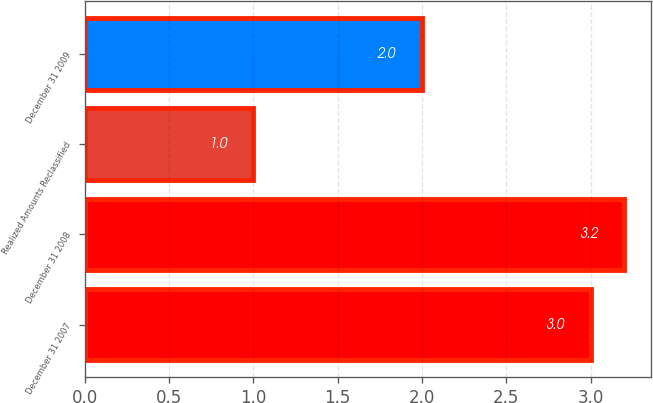<chart> <loc_0><loc_0><loc_500><loc_500><bar_chart><fcel>December 31 2007<fcel>December 31 2008<fcel>Realized Amounts Reclassified<fcel>December 31 2009<nl><fcel>3<fcel>3.2<fcel>1<fcel>2<nl></chart> 